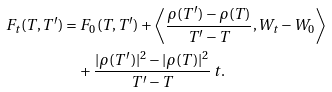Convert formula to latex. <formula><loc_0><loc_0><loc_500><loc_500>F _ { t } ( T , T ^ { \prime } ) & = F _ { 0 } ( T , T ^ { \prime } ) + \left \langle \frac { \rho ( T ^ { \prime } ) - \rho ( T ) } { T ^ { \prime } - T } , W _ { t } - W _ { 0 } \right \rangle \\ & \quad + \frac { | \rho ( T ^ { \prime } ) | ^ { 2 } - | \rho ( T ) | ^ { 2 } } { T ^ { \prime } - T } \, t .</formula> 